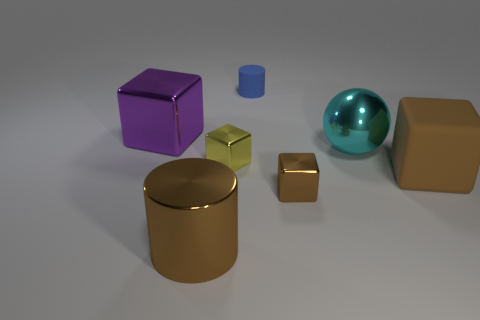Is the big shiny cylinder the same color as the big rubber thing?
Offer a very short reply. Yes. Are there any other things that are the same shape as the cyan metal thing?
Offer a terse response. No. Do the metallic thing to the left of the metallic cylinder and the metallic cylinder have the same size?
Offer a very short reply. Yes. There is a blue cylinder; how many big cyan things are in front of it?
Ensure brevity in your answer.  1. Is the number of tiny blue rubber cylinders that are in front of the purple cube less than the number of rubber cubes behind the blue matte cylinder?
Your answer should be very brief. No. How many big matte cubes are there?
Make the answer very short. 1. What color is the small object that is in front of the brown rubber cube?
Offer a very short reply. Brown. The cyan object has what size?
Your answer should be compact. Large. There is a matte cylinder; is it the same color as the large metallic object that is behind the cyan object?
Provide a succinct answer. No. There is a rubber object that is to the right of the small metal block to the right of the yellow block; what color is it?
Provide a succinct answer. Brown. 